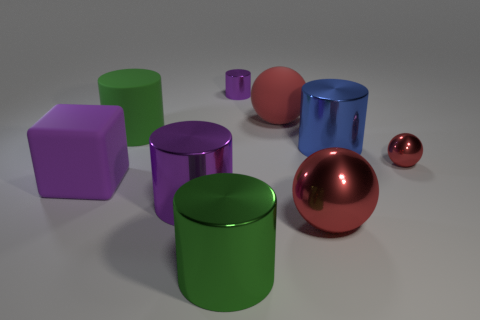Are there any large blue metallic cylinders that are behind the large metal cylinder that is on the right side of the purple cylinder that is right of the green metal cylinder?
Offer a terse response. No. What number of objects are either big matte objects that are in front of the tiny red metal object or metallic things behind the big metallic ball?
Give a very brief answer. 5. Is the material of the green cylinder that is in front of the big green matte object the same as the large cube?
Ensure brevity in your answer.  No. There is a thing that is both in front of the blue metallic cylinder and behind the purple matte thing; what material is it made of?
Offer a terse response. Metal. What color is the tiny shiny thing to the left of the large matte thing on the right side of the tiny shiny cylinder?
Your response must be concise. Purple. There is another large thing that is the same shape as the large red rubber object; what is its material?
Your response must be concise. Metal. There is a cylinder on the right side of the metallic object behind the big rubber object behind the big matte cylinder; what color is it?
Your answer should be very brief. Blue. What number of objects are big red matte objects or purple metal cylinders?
Your answer should be compact. 3. What number of other purple things are the same shape as the big purple metal thing?
Offer a terse response. 1. Do the cube and the red ball that is left of the big red metallic thing have the same material?
Offer a very short reply. Yes. 